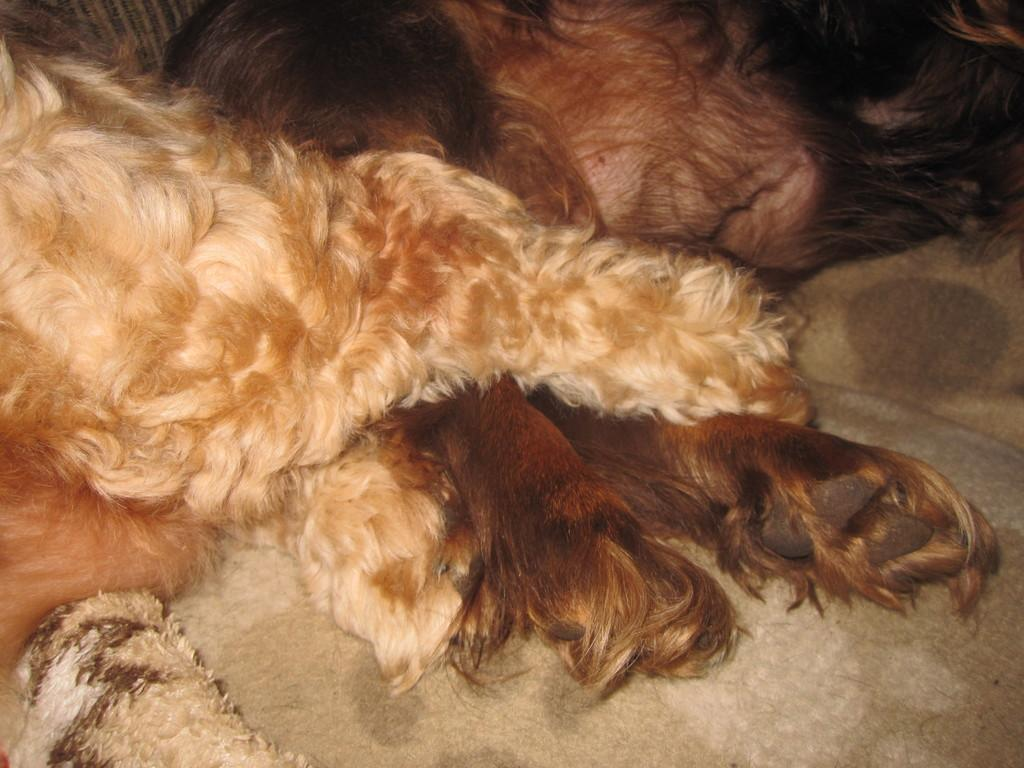What type of creature is present in the image? There is an animal in the image. Can you describe the position of the animal in the image? The animal is lying on the floor. What type of cakes can be seen in the image? There are no cakes present in the image; it features an animal lying on the floor. How does the animal's nose appear in the image? There is no mention of the animal's nose in the provided facts, so it cannot be described. 